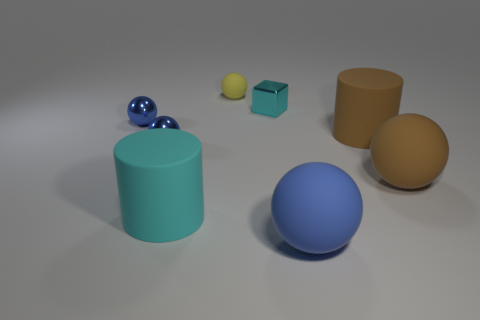There is a big brown object that is the same shape as the small yellow rubber thing; what is its material?
Offer a terse response. Rubber. There is a cyan object that is behind the cyan matte object; does it have the same shape as the large thing left of the big blue rubber ball?
Your answer should be very brief. No. Is the number of small gray rubber balls greater than the number of big blue spheres?
Your response must be concise. No. What size is the yellow rubber ball?
Ensure brevity in your answer.  Small. How many other objects are the same color as the cube?
Your answer should be very brief. 1. Do the blue thing right of the tiny cyan object and the block have the same material?
Keep it short and to the point. No. Is the number of large cyan rubber things that are on the left side of the cyan matte thing less than the number of tiny matte balls on the right side of the small cyan thing?
Make the answer very short. No. What number of other things are there of the same material as the small block
Keep it short and to the point. 2. There is a block that is the same size as the yellow object; what material is it?
Provide a succinct answer. Metal. Are there fewer metal blocks that are to the right of the blue matte thing than tiny rubber spheres?
Your answer should be very brief. Yes. 